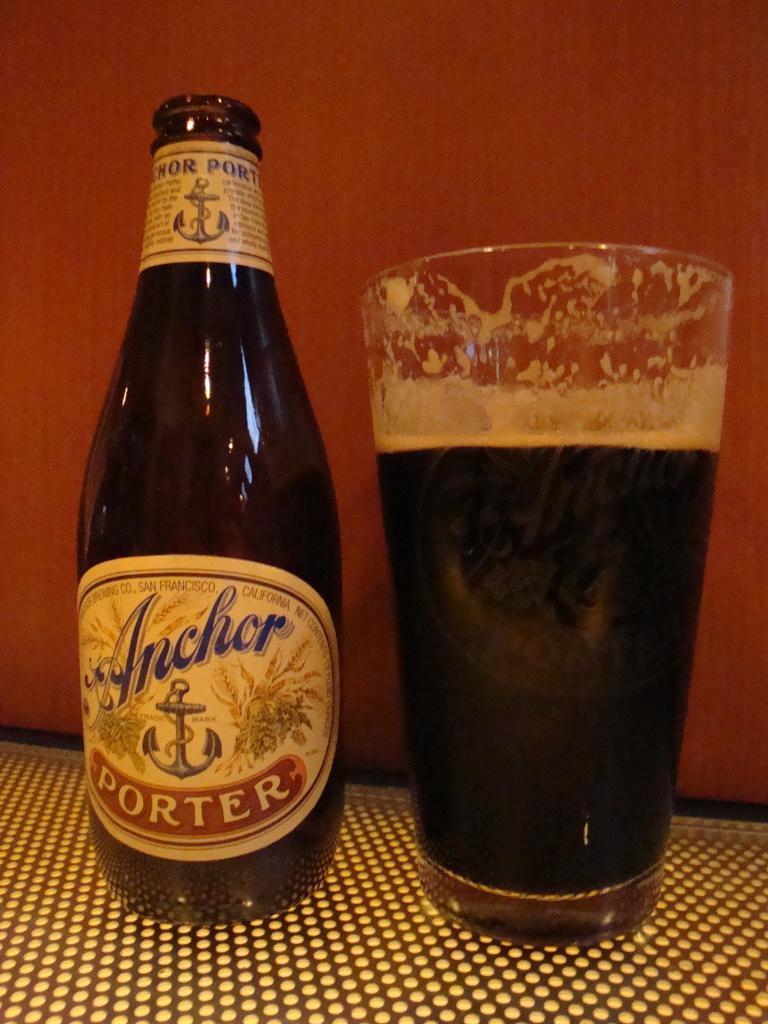In one or two sentences, can you explain what this image depicts? In this image we can see a glass full of juice and a bottle on the surface. The background is orange in color. There is a label on the bottle. 